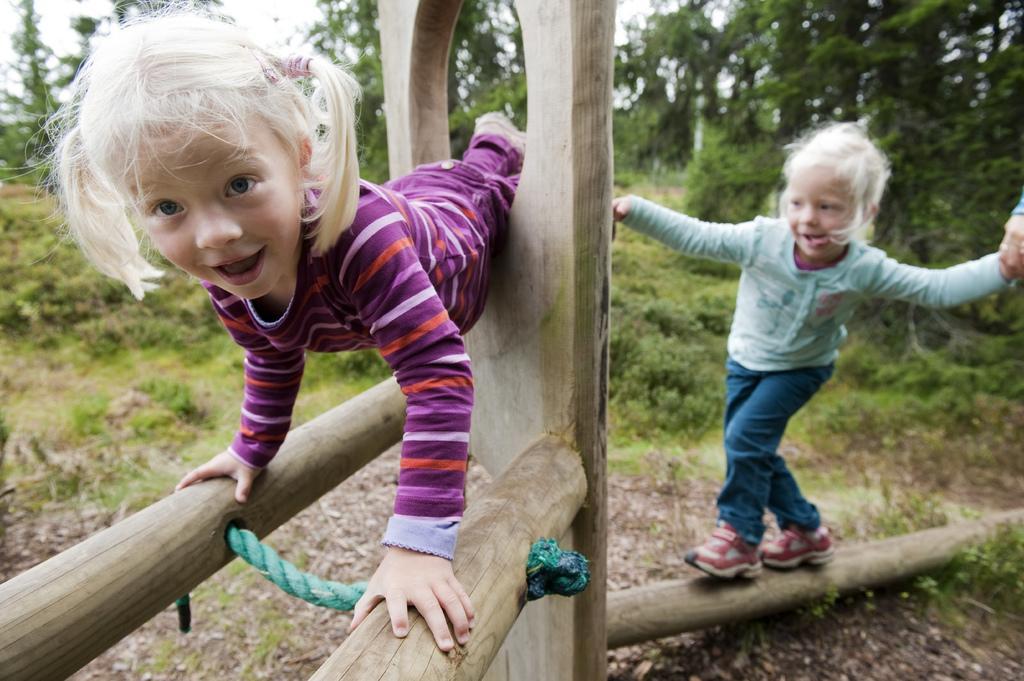Can you describe this image briefly? In this image, I can see two children playing on a wooden object. The girl who is on the left side is looking at the picture and smiling and the other child who is on the right side is walking on a trunk. In the background there are many plants and trees. 